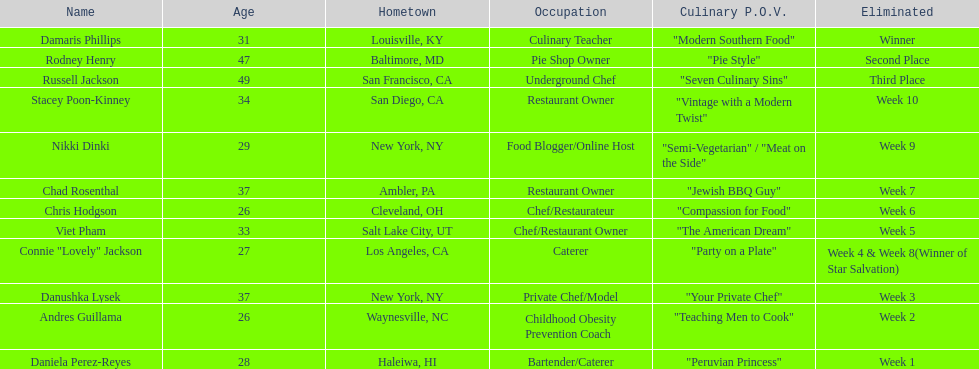How many competitors were under the age of 30? 5. 